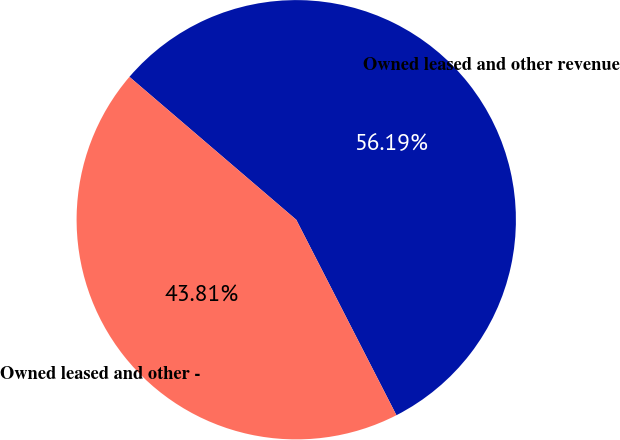Convert chart. <chart><loc_0><loc_0><loc_500><loc_500><pie_chart><fcel>Owned leased and other revenue<fcel>Owned leased and other -<nl><fcel>56.19%<fcel>43.81%<nl></chart> 